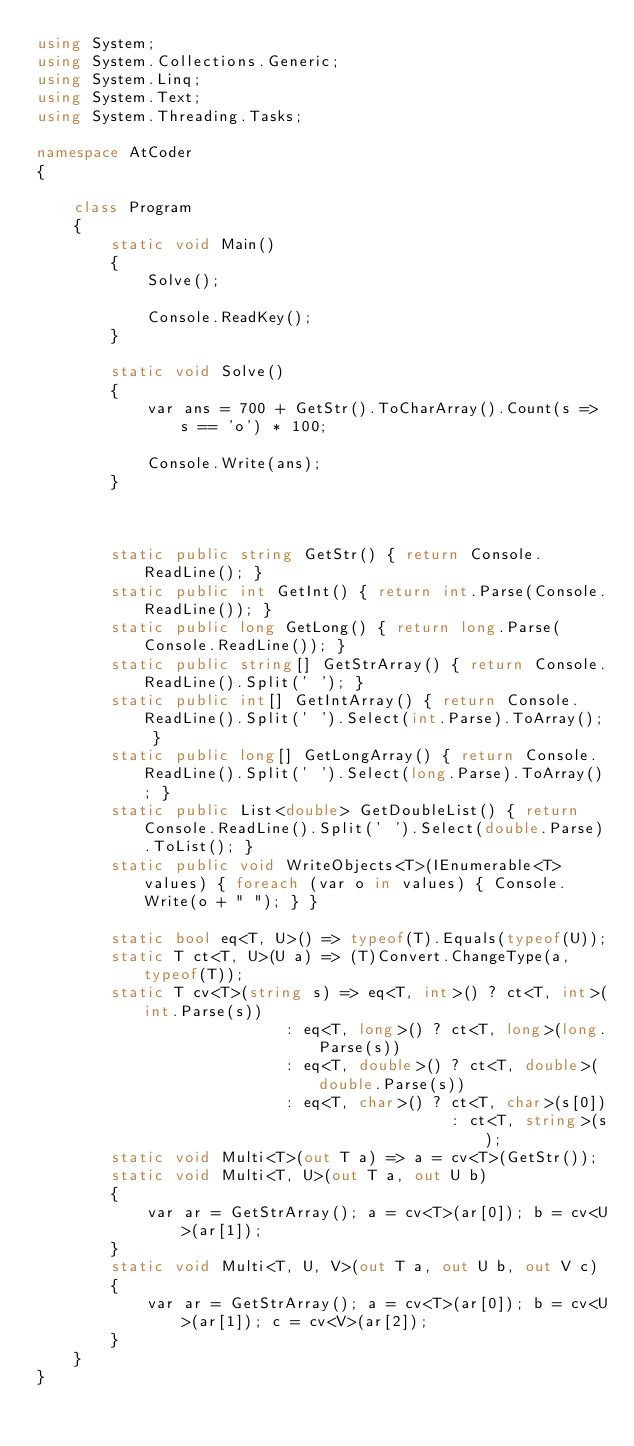<code> <loc_0><loc_0><loc_500><loc_500><_C#_>using System;
using System.Collections.Generic;
using System.Linq;
using System.Text;
using System.Threading.Tasks;

namespace AtCoder
{

    class Program
    {
        static void Main()
        {
            Solve();

            Console.ReadKey();
        }

        static void Solve()
        {
            var ans = 700 + GetStr().ToCharArray().Count(s => s == 'o') * 100;

            Console.Write(ans);
        }



        static public string GetStr() { return Console.ReadLine(); }
        static public int GetInt() { return int.Parse(Console.ReadLine()); }
        static public long GetLong() { return long.Parse(Console.ReadLine()); }
        static public string[] GetStrArray() { return Console.ReadLine().Split(' '); }
        static public int[] GetIntArray() { return Console.ReadLine().Split(' ').Select(int.Parse).ToArray(); }
        static public long[] GetLongArray() { return Console.ReadLine().Split(' ').Select(long.Parse).ToArray(); }
        static public List<double> GetDoubleList() { return Console.ReadLine().Split(' ').Select(double.Parse).ToList(); }
        static public void WriteObjects<T>(IEnumerable<T> values) { foreach (var o in values) { Console.Write(o + " "); } }

        static bool eq<T, U>() => typeof(T).Equals(typeof(U));
        static T ct<T, U>(U a) => (T)Convert.ChangeType(a, typeof(T));
        static T cv<T>(string s) => eq<T, int>() ? ct<T, int>(int.Parse(s))
                           : eq<T, long>() ? ct<T, long>(long.Parse(s))
                           : eq<T, double>() ? ct<T, double>(double.Parse(s))
                           : eq<T, char>() ? ct<T, char>(s[0])
                                             : ct<T, string>(s);
        static void Multi<T>(out T a) => a = cv<T>(GetStr());
        static void Multi<T, U>(out T a, out U b)
        {
            var ar = GetStrArray(); a = cv<T>(ar[0]); b = cv<U>(ar[1]);
        }
        static void Multi<T, U, V>(out T a, out U b, out V c)
        {
            var ar = GetStrArray(); a = cv<T>(ar[0]); b = cv<U>(ar[1]); c = cv<V>(ar[2]);
        }
    }
}</code> 